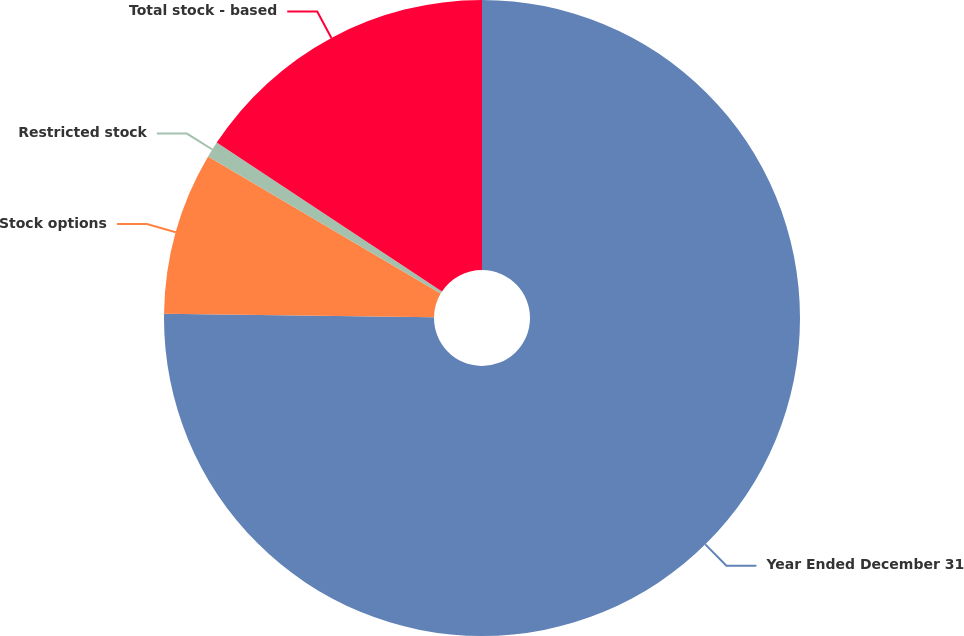Convert chart. <chart><loc_0><loc_0><loc_500><loc_500><pie_chart><fcel>Year Ended December 31<fcel>Stock options<fcel>Restricted stock<fcel>Total stock - based<nl><fcel>75.21%<fcel>8.26%<fcel>0.82%<fcel>15.7%<nl></chart> 